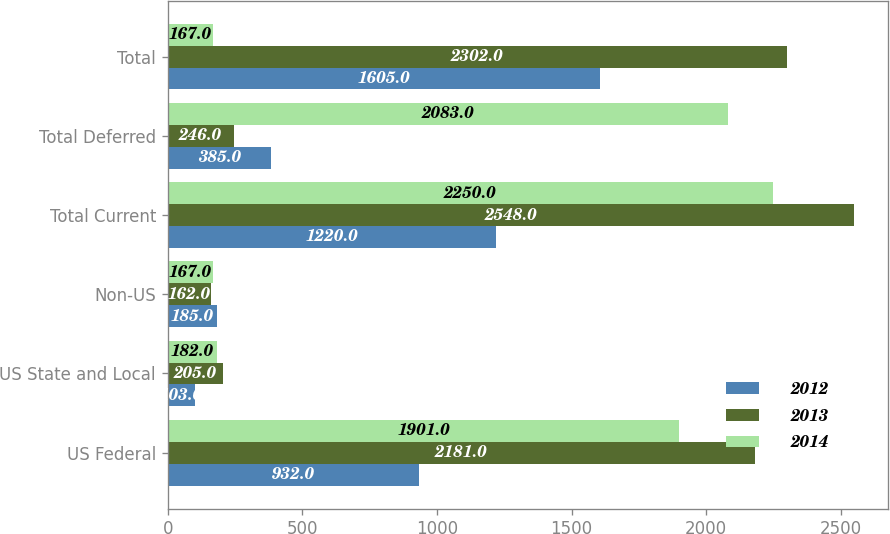Convert chart. <chart><loc_0><loc_0><loc_500><loc_500><stacked_bar_chart><ecel><fcel>US Federal<fcel>US State and Local<fcel>Non-US<fcel>Total Current<fcel>Total Deferred<fcel>Total<nl><fcel>2012<fcel>932<fcel>103<fcel>185<fcel>1220<fcel>385<fcel>1605<nl><fcel>2013<fcel>2181<fcel>205<fcel>162<fcel>2548<fcel>246<fcel>2302<nl><fcel>2014<fcel>1901<fcel>182<fcel>167<fcel>2250<fcel>2083<fcel>167<nl></chart> 